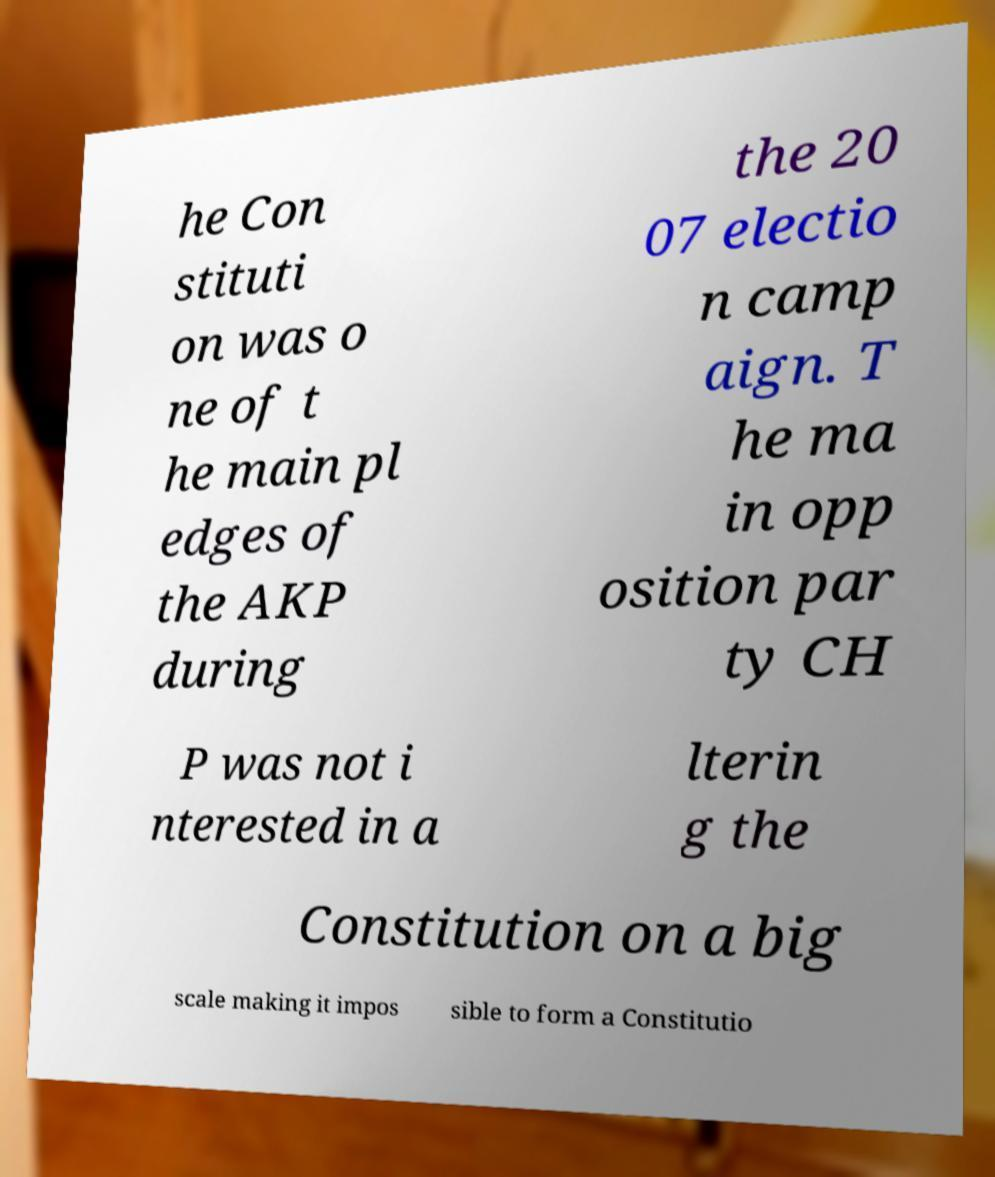Please identify and transcribe the text found in this image. he Con stituti on was o ne of t he main pl edges of the AKP during the 20 07 electio n camp aign. T he ma in opp osition par ty CH P was not i nterested in a lterin g the Constitution on a big scale making it impos sible to form a Constitutio 